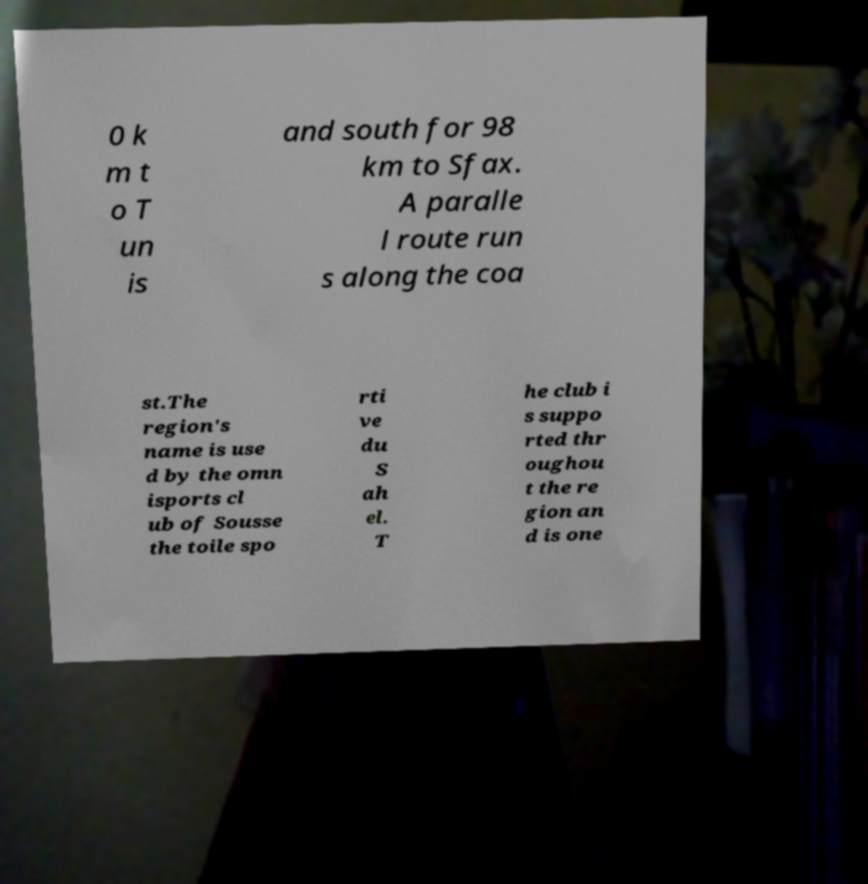Could you extract and type out the text from this image? 0 k m t o T un is and south for 98 km to Sfax. A paralle l route run s along the coa st.The region's name is use d by the omn isports cl ub of Sousse the toile spo rti ve du S ah el. T he club i s suppo rted thr oughou t the re gion an d is one 